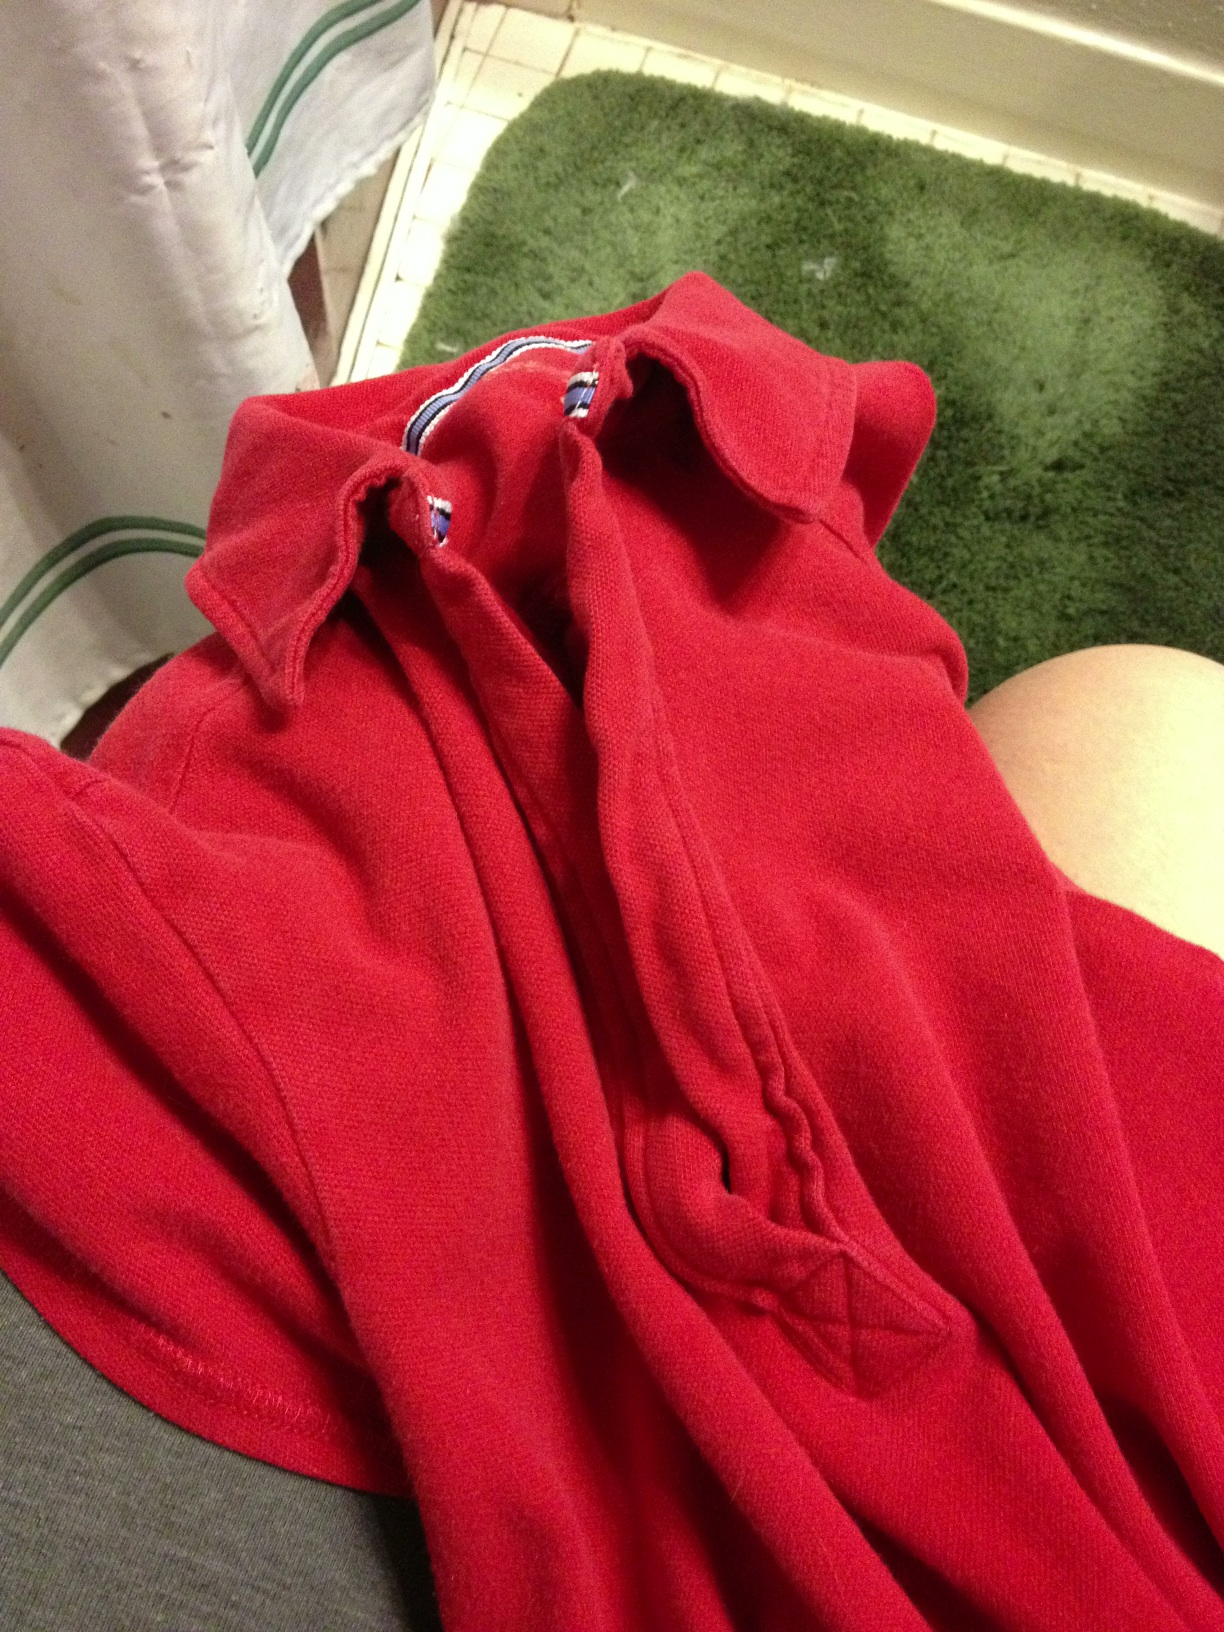What color is this shirt? from Vizwiz red 